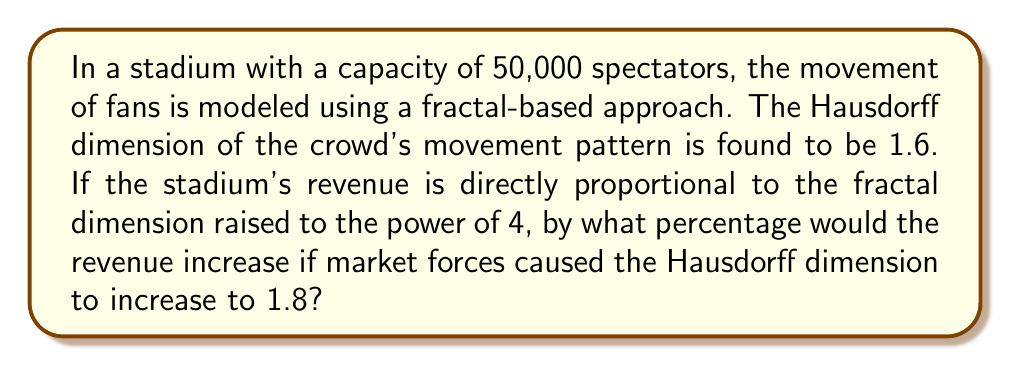Can you answer this question? To solve this problem, we'll follow these steps:

1) Let's define the revenue as R, and assume it's proportional to the Hausdorff dimension (D) raised to the power of 4:

   $R \propto D^4$

2) We can write this as an equation with some constant k:

   $R = kD^4$

3) We have two scenarios:
   Initial: $D_1 = 1.6$
   New: $D_2 = 1.8$

4) Let's calculate the revenues:
   $R_1 = k(1.6)^4$
   $R_2 = k(1.8)^4$

5) To find the percentage increase, we use the formula:
   Percentage increase = $\frac{R_2 - R_1}{R_1} \times 100\%$

6) Substituting:
   Percentage increase = $\frac{k(1.8)^4 - k(1.6)^4}{k(1.6)^4} \times 100\%$

7) The k cancels out:
   Percentage increase = $\frac{(1.8)^4 - (1.6)^4}{(1.6)^4} \times 100\%$

8) Calculate:
   $(1.8)^4 = 10.4976$
   $(1.6)^4 = 6.5536$

9) Substituting:
   Percentage increase = $\frac{10.4976 - 6.5536}{6.5536} \times 100\%$
                       = $\frac{3.944}{6.5536} \times 100\%$
                       = 0.6018 \times 100\%$
                       = 60.18\%$

Therefore, the revenue would increase by approximately 60.18%.
Answer: 60.18% 